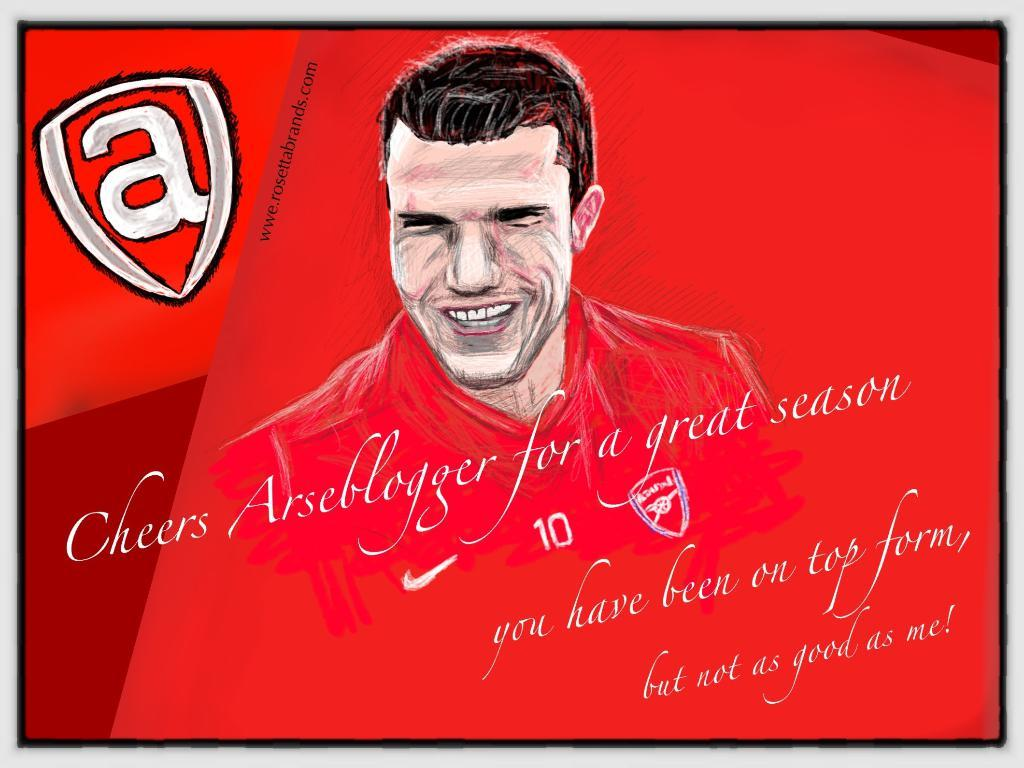What type of image is present in the picture? There is a cartoon image of a man in the picture. Where can text be found in the picture? Text can be found at the top left corner and the bottom of the picture. Can you describe the card that the man is holding in the picture? There is no card present in the picture; it only features a cartoon image of a man and text. How does the man interact with the bath in the picture? There is no bath present in the picture; it only features a cartoon image of a man and text. 